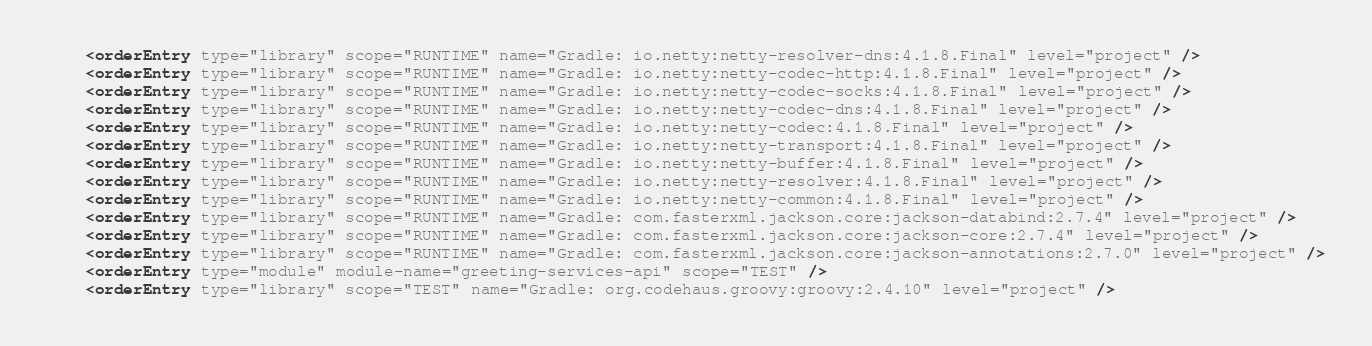Convert code to text. <code><loc_0><loc_0><loc_500><loc_500><_XML_>    <orderEntry type="library" scope="RUNTIME" name="Gradle: io.netty:netty-resolver-dns:4.1.8.Final" level="project" />
    <orderEntry type="library" scope="RUNTIME" name="Gradle: io.netty:netty-codec-http:4.1.8.Final" level="project" />
    <orderEntry type="library" scope="RUNTIME" name="Gradle: io.netty:netty-codec-socks:4.1.8.Final" level="project" />
    <orderEntry type="library" scope="RUNTIME" name="Gradle: io.netty:netty-codec-dns:4.1.8.Final" level="project" />
    <orderEntry type="library" scope="RUNTIME" name="Gradle: io.netty:netty-codec:4.1.8.Final" level="project" />
    <orderEntry type="library" scope="RUNTIME" name="Gradle: io.netty:netty-transport:4.1.8.Final" level="project" />
    <orderEntry type="library" scope="RUNTIME" name="Gradle: io.netty:netty-buffer:4.1.8.Final" level="project" />
    <orderEntry type="library" scope="RUNTIME" name="Gradle: io.netty:netty-resolver:4.1.8.Final" level="project" />
    <orderEntry type="library" scope="RUNTIME" name="Gradle: io.netty:netty-common:4.1.8.Final" level="project" />
    <orderEntry type="library" scope="RUNTIME" name="Gradle: com.fasterxml.jackson.core:jackson-databind:2.7.4" level="project" />
    <orderEntry type="library" scope="RUNTIME" name="Gradle: com.fasterxml.jackson.core:jackson-core:2.7.4" level="project" />
    <orderEntry type="library" scope="RUNTIME" name="Gradle: com.fasterxml.jackson.core:jackson-annotations:2.7.0" level="project" />
    <orderEntry type="module" module-name="greeting-services-api" scope="TEST" />
    <orderEntry type="library" scope="TEST" name="Gradle: org.codehaus.groovy:groovy:2.4.10" level="project" /></code> 